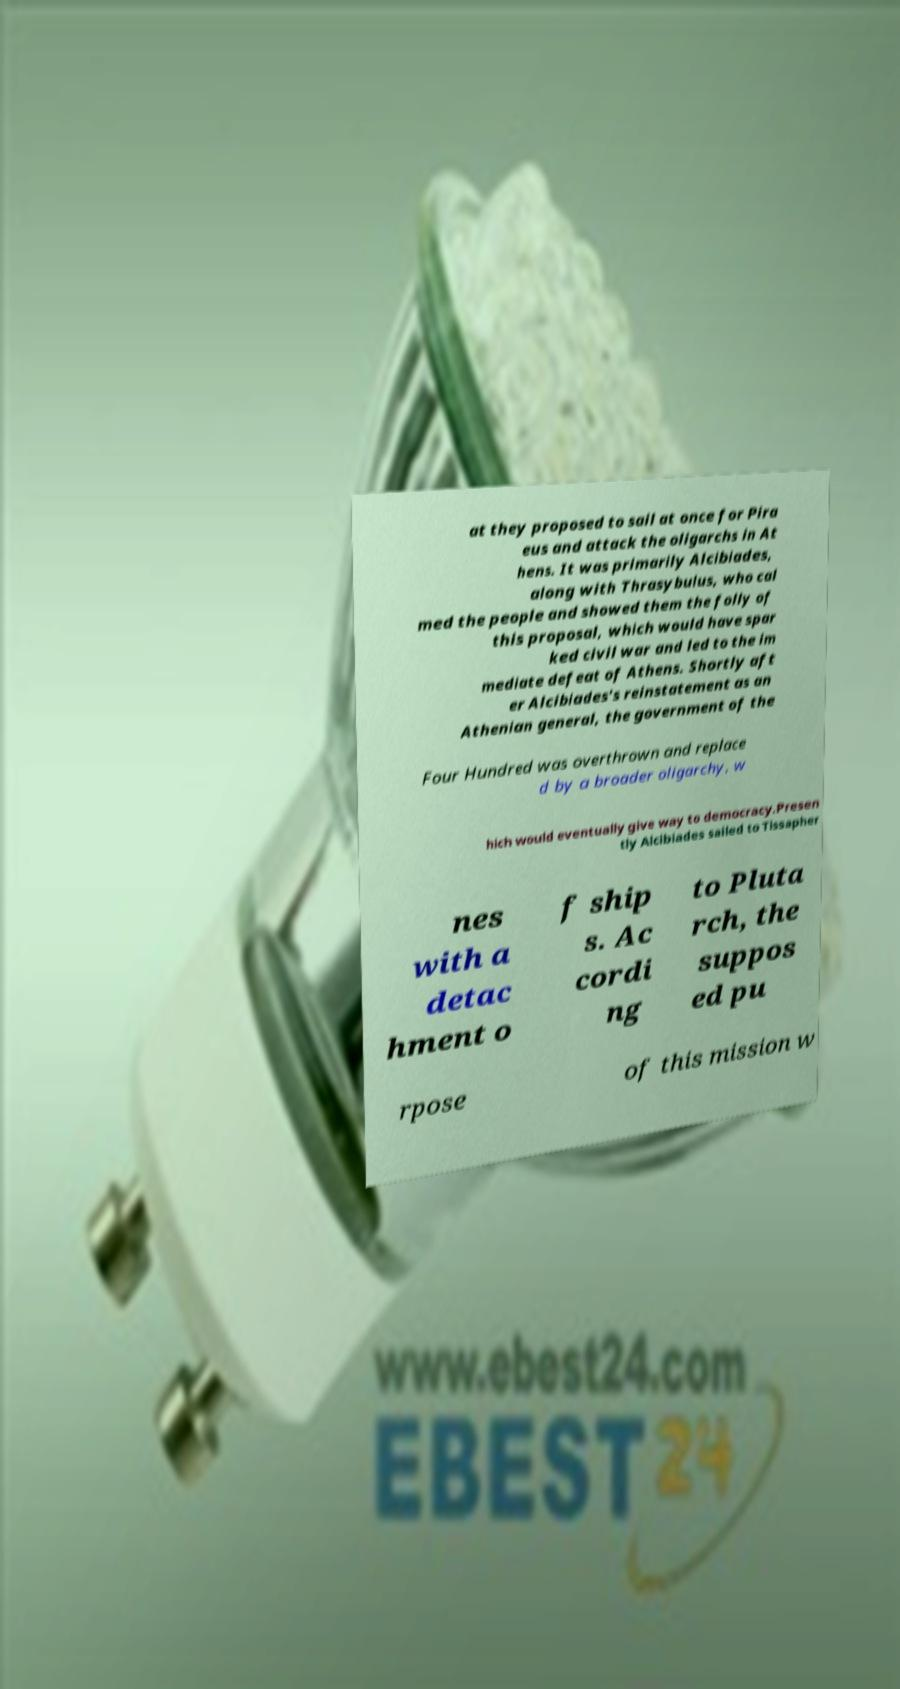Please read and relay the text visible in this image. What does it say? at they proposed to sail at once for Pira eus and attack the oligarchs in At hens. It was primarily Alcibiades, along with Thrasybulus, who cal med the people and showed them the folly of this proposal, which would have spar ked civil war and led to the im mediate defeat of Athens. Shortly aft er Alcibiades's reinstatement as an Athenian general, the government of the Four Hundred was overthrown and replace d by a broader oligarchy, w hich would eventually give way to democracy.Presen tly Alcibiades sailed to Tissapher nes with a detac hment o f ship s. Ac cordi ng to Pluta rch, the suppos ed pu rpose of this mission w 